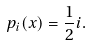Convert formula to latex. <formula><loc_0><loc_0><loc_500><loc_500>p _ { i } ( x ) = \frac { 1 } { 2 } i .</formula> 